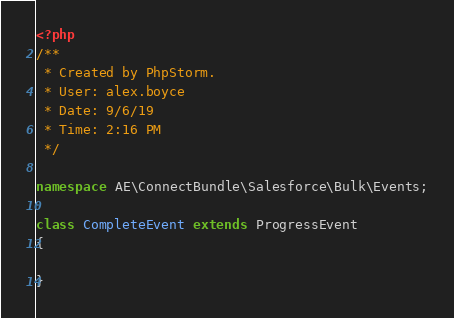<code> <loc_0><loc_0><loc_500><loc_500><_PHP_><?php
/**
 * Created by PhpStorm.
 * User: alex.boyce
 * Date: 9/6/19
 * Time: 2:16 PM
 */

namespace AE\ConnectBundle\Salesforce\Bulk\Events;

class CompleteEvent extends ProgressEvent
{

}
</code> 